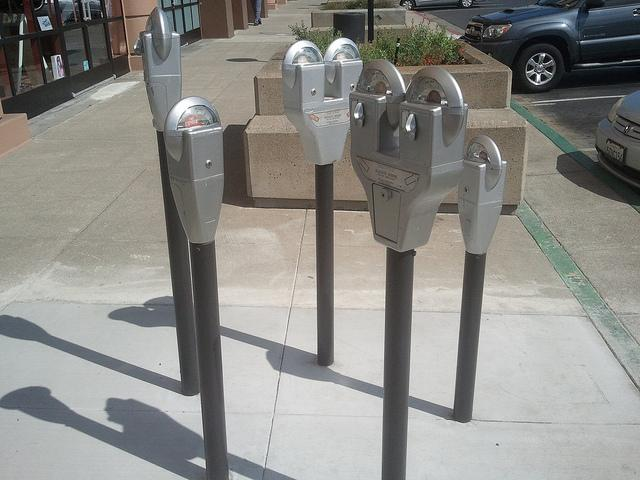How many cars do these meters currently monitor?

Choices:
A) one
B) none
C) two
D) nine none 